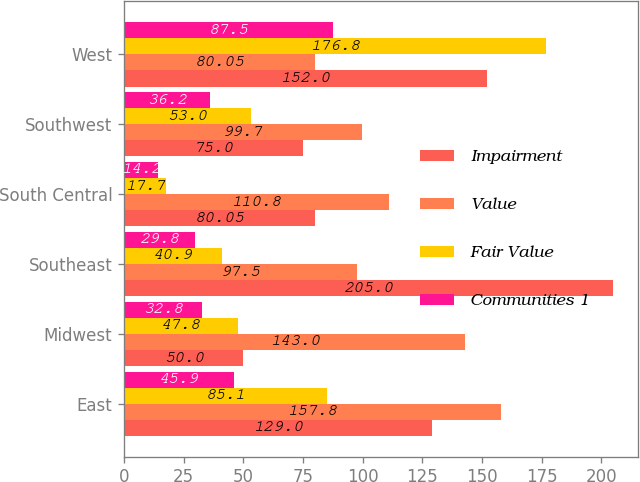<chart> <loc_0><loc_0><loc_500><loc_500><stacked_bar_chart><ecel><fcel>East<fcel>Midwest<fcel>Southeast<fcel>South Central<fcel>Southwest<fcel>West<nl><fcel>Impairment<fcel>129<fcel>50<fcel>205<fcel>80.05<fcel>75<fcel>152<nl><fcel>Value<fcel>157.8<fcel>143<fcel>97.5<fcel>110.8<fcel>99.7<fcel>80.05<nl><fcel>Fair Value<fcel>85.1<fcel>47.8<fcel>40.9<fcel>17.7<fcel>53<fcel>176.8<nl><fcel>Communities 1<fcel>45.9<fcel>32.8<fcel>29.8<fcel>14.2<fcel>36.2<fcel>87.5<nl></chart> 